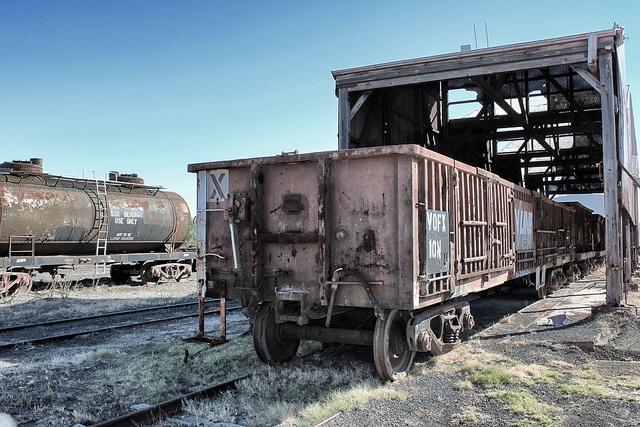Describe the objects in this image and their specific colors. I can see train in gray, black, and darkgray tones and train in gray, darkgray, black, and lightgray tones in this image. 